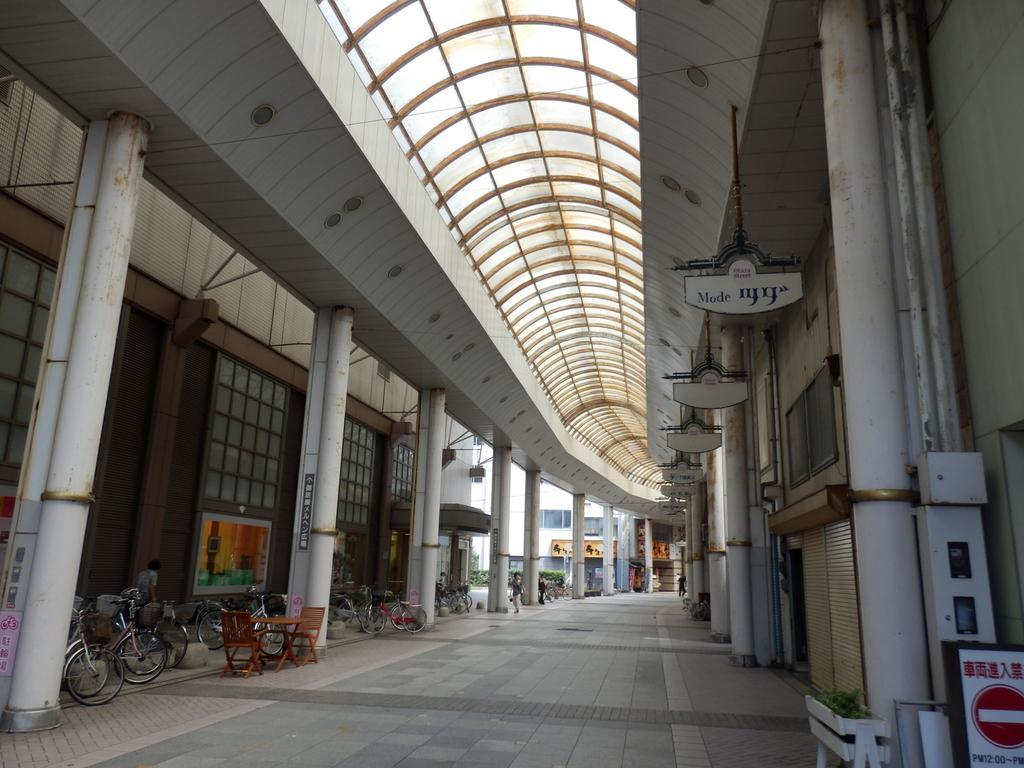Could you give a brief overview of what you see in this image? In this image we could see some pillars, tables, chairs, cycles, plants, boards, shutters, glass doors, buildings. At the bottom there is a walkway, and in the background there are some people walking and at the top it looks like a ceiling. And on the left side and right side of the image there might be a bridge. 